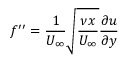Convert formula to latex. <formula><loc_0><loc_0><loc_500><loc_500>f ^ { \prime \prime } = \frac { 1 } { U _ { \infty } } \sqrt { \frac { \nu x } { U _ { \infty } } } \frac { \partial u } { \partial y }</formula> 